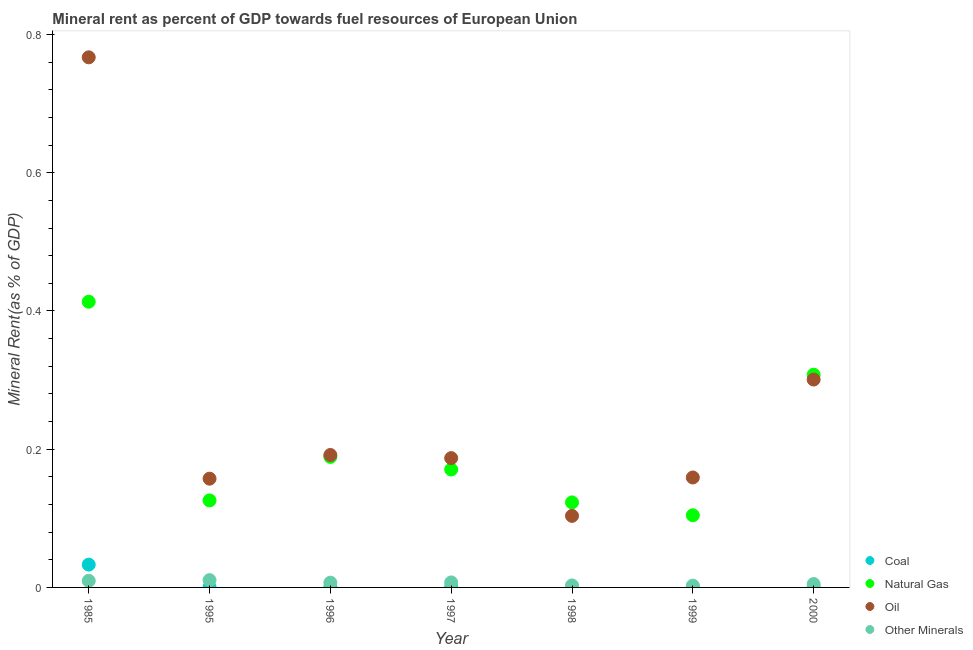Is the number of dotlines equal to the number of legend labels?
Keep it short and to the point. Yes. What is the  rent of other minerals in 1985?
Your response must be concise. 0.01. Across all years, what is the maximum oil rent?
Your response must be concise. 0.77. Across all years, what is the minimum oil rent?
Provide a short and direct response. 0.1. In which year was the oil rent minimum?
Provide a succinct answer. 1998. What is the total oil rent in the graph?
Your answer should be compact. 1.87. What is the difference between the natural gas rent in 1996 and that in 1998?
Your answer should be very brief. 0.07. What is the difference between the coal rent in 1985 and the oil rent in 1998?
Ensure brevity in your answer.  -0.07. What is the average natural gas rent per year?
Your answer should be compact. 0.2. In the year 1999, what is the difference between the oil rent and coal rent?
Ensure brevity in your answer.  0.16. What is the ratio of the  rent of other minerals in 1985 to that in 1996?
Provide a short and direct response. 1.39. What is the difference between the highest and the second highest natural gas rent?
Give a very brief answer. 0.11. What is the difference between the highest and the lowest oil rent?
Make the answer very short. 0.66. In how many years, is the natural gas rent greater than the average natural gas rent taken over all years?
Make the answer very short. 2. Is the sum of the natural gas rent in 1995 and 2000 greater than the maximum oil rent across all years?
Make the answer very short. No. Does the natural gas rent monotonically increase over the years?
Offer a very short reply. No. Is the  rent of other minerals strictly greater than the oil rent over the years?
Make the answer very short. No. Is the natural gas rent strictly less than the  rent of other minerals over the years?
Your answer should be compact. No. Are the values on the major ticks of Y-axis written in scientific E-notation?
Keep it short and to the point. No. Does the graph contain any zero values?
Offer a very short reply. No. Does the graph contain grids?
Keep it short and to the point. No. Where does the legend appear in the graph?
Provide a short and direct response. Bottom right. How many legend labels are there?
Your response must be concise. 4. What is the title of the graph?
Ensure brevity in your answer.  Mineral rent as percent of GDP towards fuel resources of European Union. What is the label or title of the X-axis?
Provide a short and direct response. Year. What is the label or title of the Y-axis?
Offer a very short reply. Mineral Rent(as % of GDP). What is the Mineral Rent(as % of GDP) in Coal in 1985?
Make the answer very short. 0.03. What is the Mineral Rent(as % of GDP) in Natural Gas in 1985?
Ensure brevity in your answer.  0.41. What is the Mineral Rent(as % of GDP) in Oil in 1985?
Your answer should be compact. 0.77. What is the Mineral Rent(as % of GDP) of Other Minerals in 1985?
Provide a succinct answer. 0.01. What is the Mineral Rent(as % of GDP) of Coal in 1995?
Your answer should be very brief. 0. What is the Mineral Rent(as % of GDP) in Natural Gas in 1995?
Offer a terse response. 0.13. What is the Mineral Rent(as % of GDP) in Oil in 1995?
Make the answer very short. 0.16. What is the Mineral Rent(as % of GDP) of Other Minerals in 1995?
Keep it short and to the point. 0.01. What is the Mineral Rent(as % of GDP) of Coal in 1996?
Make the answer very short. 0. What is the Mineral Rent(as % of GDP) of Natural Gas in 1996?
Your response must be concise. 0.19. What is the Mineral Rent(as % of GDP) in Oil in 1996?
Offer a very short reply. 0.19. What is the Mineral Rent(as % of GDP) of Other Minerals in 1996?
Your answer should be very brief. 0.01. What is the Mineral Rent(as % of GDP) in Coal in 1997?
Offer a very short reply. 0. What is the Mineral Rent(as % of GDP) of Natural Gas in 1997?
Keep it short and to the point. 0.17. What is the Mineral Rent(as % of GDP) of Oil in 1997?
Give a very brief answer. 0.19. What is the Mineral Rent(as % of GDP) of Other Minerals in 1997?
Your answer should be very brief. 0.01. What is the Mineral Rent(as % of GDP) of Coal in 1998?
Your answer should be compact. 0. What is the Mineral Rent(as % of GDP) of Natural Gas in 1998?
Ensure brevity in your answer.  0.12. What is the Mineral Rent(as % of GDP) of Oil in 1998?
Give a very brief answer. 0.1. What is the Mineral Rent(as % of GDP) in Other Minerals in 1998?
Ensure brevity in your answer.  0. What is the Mineral Rent(as % of GDP) of Coal in 1999?
Provide a short and direct response. 7.968829103317441e-5. What is the Mineral Rent(as % of GDP) in Natural Gas in 1999?
Offer a terse response. 0.1. What is the Mineral Rent(as % of GDP) of Oil in 1999?
Offer a terse response. 0.16. What is the Mineral Rent(as % of GDP) in Other Minerals in 1999?
Your answer should be compact. 0. What is the Mineral Rent(as % of GDP) in Coal in 2000?
Make the answer very short. 0. What is the Mineral Rent(as % of GDP) of Natural Gas in 2000?
Your answer should be very brief. 0.31. What is the Mineral Rent(as % of GDP) of Oil in 2000?
Your answer should be very brief. 0.3. What is the Mineral Rent(as % of GDP) in Other Minerals in 2000?
Keep it short and to the point. 0. Across all years, what is the maximum Mineral Rent(as % of GDP) in Coal?
Offer a very short reply. 0.03. Across all years, what is the maximum Mineral Rent(as % of GDP) in Natural Gas?
Provide a succinct answer. 0.41. Across all years, what is the maximum Mineral Rent(as % of GDP) in Oil?
Provide a succinct answer. 0.77. Across all years, what is the maximum Mineral Rent(as % of GDP) of Other Minerals?
Keep it short and to the point. 0.01. Across all years, what is the minimum Mineral Rent(as % of GDP) in Coal?
Offer a very short reply. 7.968829103317441e-5. Across all years, what is the minimum Mineral Rent(as % of GDP) in Natural Gas?
Provide a succinct answer. 0.1. Across all years, what is the minimum Mineral Rent(as % of GDP) of Oil?
Offer a very short reply. 0.1. Across all years, what is the minimum Mineral Rent(as % of GDP) of Other Minerals?
Ensure brevity in your answer.  0. What is the total Mineral Rent(as % of GDP) of Coal in the graph?
Ensure brevity in your answer.  0.03. What is the total Mineral Rent(as % of GDP) in Natural Gas in the graph?
Offer a terse response. 1.43. What is the total Mineral Rent(as % of GDP) of Oil in the graph?
Your response must be concise. 1.87. What is the total Mineral Rent(as % of GDP) in Other Minerals in the graph?
Provide a short and direct response. 0.04. What is the difference between the Mineral Rent(as % of GDP) of Coal in 1985 and that in 1995?
Provide a short and direct response. 0.03. What is the difference between the Mineral Rent(as % of GDP) of Natural Gas in 1985 and that in 1995?
Make the answer very short. 0.29. What is the difference between the Mineral Rent(as % of GDP) in Oil in 1985 and that in 1995?
Keep it short and to the point. 0.61. What is the difference between the Mineral Rent(as % of GDP) in Other Minerals in 1985 and that in 1995?
Your answer should be very brief. -0. What is the difference between the Mineral Rent(as % of GDP) in Coal in 1985 and that in 1996?
Give a very brief answer. 0.03. What is the difference between the Mineral Rent(as % of GDP) in Natural Gas in 1985 and that in 1996?
Keep it short and to the point. 0.22. What is the difference between the Mineral Rent(as % of GDP) of Oil in 1985 and that in 1996?
Your answer should be compact. 0.58. What is the difference between the Mineral Rent(as % of GDP) of Other Minerals in 1985 and that in 1996?
Offer a very short reply. 0. What is the difference between the Mineral Rent(as % of GDP) of Coal in 1985 and that in 1997?
Ensure brevity in your answer.  0.03. What is the difference between the Mineral Rent(as % of GDP) of Natural Gas in 1985 and that in 1997?
Offer a terse response. 0.24. What is the difference between the Mineral Rent(as % of GDP) in Oil in 1985 and that in 1997?
Give a very brief answer. 0.58. What is the difference between the Mineral Rent(as % of GDP) of Other Minerals in 1985 and that in 1997?
Make the answer very short. 0. What is the difference between the Mineral Rent(as % of GDP) of Coal in 1985 and that in 1998?
Keep it short and to the point. 0.03. What is the difference between the Mineral Rent(as % of GDP) in Natural Gas in 1985 and that in 1998?
Your answer should be compact. 0.29. What is the difference between the Mineral Rent(as % of GDP) of Oil in 1985 and that in 1998?
Your answer should be very brief. 0.66. What is the difference between the Mineral Rent(as % of GDP) in Other Minerals in 1985 and that in 1998?
Your answer should be compact. 0.01. What is the difference between the Mineral Rent(as % of GDP) in Coal in 1985 and that in 1999?
Provide a succinct answer. 0.03. What is the difference between the Mineral Rent(as % of GDP) of Natural Gas in 1985 and that in 1999?
Give a very brief answer. 0.31. What is the difference between the Mineral Rent(as % of GDP) in Oil in 1985 and that in 1999?
Your answer should be compact. 0.61. What is the difference between the Mineral Rent(as % of GDP) of Other Minerals in 1985 and that in 1999?
Provide a short and direct response. 0.01. What is the difference between the Mineral Rent(as % of GDP) of Coal in 1985 and that in 2000?
Make the answer very short. 0.03. What is the difference between the Mineral Rent(as % of GDP) in Natural Gas in 1985 and that in 2000?
Provide a short and direct response. 0.11. What is the difference between the Mineral Rent(as % of GDP) in Oil in 1985 and that in 2000?
Provide a short and direct response. 0.47. What is the difference between the Mineral Rent(as % of GDP) of Other Minerals in 1985 and that in 2000?
Give a very brief answer. 0. What is the difference between the Mineral Rent(as % of GDP) in Natural Gas in 1995 and that in 1996?
Your answer should be compact. -0.06. What is the difference between the Mineral Rent(as % of GDP) in Oil in 1995 and that in 1996?
Give a very brief answer. -0.03. What is the difference between the Mineral Rent(as % of GDP) of Other Minerals in 1995 and that in 1996?
Give a very brief answer. 0. What is the difference between the Mineral Rent(as % of GDP) in Coal in 1995 and that in 1997?
Provide a short and direct response. 0. What is the difference between the Mineral Rent(as % of GDP) in Natural Gas in 1995 and that in 1997?
Your answer should be compact. -0.04. What is the difference between the Mineral Rent(as % of GDP) in Oil in 1995 and that in 1997?
Keep it short and to the point. -0.03. What is the difference between the Mineral Rent(as % of GDP) of Other Minerals in 1995 and that in 1997?
Provide a succinct answer. 0. What is the difference between the Mineral Rent(as % of GDP) of Coal in 1995 and that in 1998?
Your answer should be compact. 0. What is the difference between the Mineral Rent(as % of GDP) in Natural Gas in 1995 and that in 1998?
Make the answer very short. 0. What is the difference between the Mineral Rent(as % of GDP) of Oil in 1995 and that in 1998?
Offer a very short reply. 0.05. What is the difference between the Mineral Rent(as % of GDP) of Other Minerals in 1995 and that in 1998?
Offer a very short reply. 0.01. What is the difference between the Mineral Rent(as % of GDP) of Natural Gas in 1995 and that in 1999?
Provide a short and direct response. 0.02. What is the difference between the Mineral Rent(as % of GDP) in Oil in 1995 and that in 1999?
Provide a short and direct response. -0. What is the difference between the Mineral Rent(as % of GDP) in Other Minerals in 1995 and that in 1999?
Your answer should be compact. 0.01. What is the difference between the Mineral Rent(as % of GDP) of Coal in 1995 and that in 2000?
Your answer should be very brief. 0. What is the difference between the Mineral Rent(as % of GDP) in Natural Gas in 1995 and that in 2000?
Your response must be concise. -0.18. What is the difference between the Mineral Rent(as % of GDP) in Oil in 1995 and that in 2000?
Your answer should be very brief. -0.14. What is the difference between the Mineral Rent(as % of GDP) in Other Minerals in 1995 and that in 2000?
Provide a short and direct response. 0.01. What is the difference between the Mineral Rent(as % of GDP) of Natural Gas in 1996 and that in 1997?
Give a very brief answer. 0.02. What is the difference between the Mineral Rent(as % of GDP) of Oil in 1996 and that in 1997?
Your answer should be very brief. 0. What is the difference between the Mineral Rent(as % of GDP) in Other Minerals in 1996 and that in 1997?
Provide a short and direct response. -0. What is the difference between the Mineral Rent(as % of GDP) in Natural Gas in 1996 and that in 1998?
Your answer should be very brief. 0.07. What is the difference between the Mineral Rent(as % of GDP) of Oil in 1996 and that in 1998?
Your answer should be compact. 0.09. What is the difference between the Mineral Rent(as % of GDP) of Other Minerals in 1996 and that in 1998?
Keep it short and to the point. 0. What is the difference between the Mineral Rent(as % of GDP) of Natural Gas in 1996 and that in 1999?
Provide a short and direct response. 0.08. What is the difference between the Mineral Rent(as % of GDP) of Oil in 1996 and that in 1999?
Your answer should be compact. 0.03. What is the difference between the Mineral Rent(as % of GDP) in Other Minerals in 1996 and that in 1999?
Provide a succinct answer. 0. What is the difference between the Mineral Rent(as % of GDP) of Coal in 1996 and that in 2000?
Make the answer very short. 0. What is the difference between the Mineral Rent(as % of GDP) of Natural Gas in 1996 and that in 2000?
Provide a short and direct response. -0.12. What is the difference between the Mineral Rent(as % of GDP) of Oil in 1996 and that in 2000?
Your answer should be very brief. -0.11. What is the difference between the Mineral Rent(as % of GDP) in Other Minerals in 1996 and that in 2000?
Your answer should be compact. 0. What is the difference between the Mineral Rent(as % of GDP) in Natural Gas in 1997 and that in 1998?
Offer a very short reply. 0.05. What is the difference between the Mineral Rent(as % of GDP) in Oil in 1997 and that in 1998?
Ensure brevity in your answer.  0.08. What is the difference between the Mineral Rent(as % of GDP) of Other Minerals in 1997 and that in 1998?
Make the answer very short. 0. What is the difference between the Mineral Rent(as % of GDP) in Natural Gas in 1997 and that in 1999?
Ensure brevity in your answer.  0.07. What is the difference between the Mineral Rent(as % of GDP) of Oil in 1997 and that in 1999?
Provide a short and direct response. 0.03. What is the difference between the Mineral Rent(as % of GDP) in Other Minerals in 1997 and that in 1999?
Offer a terse response. 0. What is the difference between the Mineral Rent(as % of GDP) of Coal in 1997 and that in 2000?
Your response must be concise. 0. What is the difference between the Mineral Rent(as % of GDP) of Natural Gas in 1997 and that in 2000?
Your answer should be compact. -0.14. What is the difference between the Mineral Rent(as % of GDP) in Oil in 1997 and that in 2000?
Make the answer very short. -0.11. What is the difference between the Mineral Rent(as % of GDP) of Other Minerals in 1997 and that in 2000?
Your response must be concise. 0. What is the difference between the Mineral Rent(as % of GDP) in Natural Gas in 1998 and that in 1999?
Your response must be concise. 0.02. What is the difference between the Mineral Rent(as % of GDP) in Oil in 1998 and that in 1999?
Offer a terse response. -0.06. What is the difference between the Mineral Rent(as % of GDP) in Natural Gas in 1998 and that in 2000?
Your answer should be compact. -0.18. What is the difference between the Mineral Rent(as % of GDP) in Oil in 1998 and that in 2000?
Keep it short and to the point. -0.2. What is the difference between the Mineral Rent(as % of GDP) in Other Minerals in 1998 and that in 2000?
Give a very brief answer. -0. What is the difference between the Mineral Rent(as % of GDP) of Coal in 1999 and that in 2000?
Offer a terse response. -0. What is the difference between the Mineral Rent(as % of GDP) in Natural Gas in 1999 and that in 2000?
Give a very brief answer. -0.2. What is the difference between the Mineral Rent(as % of GDP) in Oil in 1999 and that in 2000?
Your answer should be compact. -0.14. What is the difference between the Mineral Rent(as % of GDP) of Other Minerals in 1999 and that in 2000?
Offer a very short reply. -0. What is the difference between the Mineral Rent(as % of GDP) of Coal in 1985 and the Mineral Rent(as % of GDP) of Natural Gas in 1995?
Offer a very short reply. -0.09. What is the difference between the Mineral Rent(as % of GDP) of Coal in 1985 and the Mineral Rent(as % of GDP) of Oil in 1995?
Give a very brief answer. -0.12. What is the difference between the Mineral Rent(as % of GDP) of Coal in 1985 and the Mineral Rent(as % of GDP) of Other Minerals in 1995?
Offer a very short reply. 0.02. What is the difference between the Mineral Rent(as % of GDP) of Natural Gas in 1985 and the Mineral Rent(as % of GDP) of Oil in 1995?
Keep it short and to the point. 0.26. What is the difference between the Mineral Rent(as % of GDP) of Natural Gas in 1985 and the Mineral Rent(as % of GDP) of Other Minerals in 1995?
Provide a succinct answer. 0.4. What is the difference between the Mineral Rent(as % of GDP) of Oil in 1985 and the Mineral Rent(as % of GDP) of Other Minerals in 1995?
Provide a succinct answer. 0.76. What is the difference between the Mineral Rent(as % of GDP) of Coal in 1985 and the Mineral Rent(as % of GDP) of Natural Gas in 1996?
Make the answer very short. -0.16. What is the difference between the Mineral Rent(as % of GDP) in Coal in 1985 and the Mineral Rent(as % of GDP) in Oil in 1996?
Make the answer very short. -0.16. What is the difference between the Mineral Rent(as % of GDP) of Coal in 1985 and the Mineral Rent(as % of GDP) of Other Minerals in 1996?
Provide a short and direct response. 0.03. What is the difference between the Mineral Rent(as % of GDP) of Natural Gas in 1985 and the Mineral Rent(as % of GDP) of Oil in 1996?
Your response must be concise. 0.22. What is the difference between the Mineral Rent(as % of GDP) in Natural Gas in 1985 and the Mineral Rent(as % of GDP) in Other Minerals in 1996?
Offer a terse response. 0.41. What is the difference between the Mineral Rent(as % of GDP) of Oil in 1985 and the Mineral Rent(as % of GDP) of Other Minerals in 1996?
Provide a succinct answer. 0.76. What is the difference between the Mineral Rent(as % of GDP) of Coal in 1985 and the Mineral Rent(as % of GDP) of Natural Gas in 1997?
Your answer should be compact. -0.14. What is the difference between the Mineral Rent(as % of GDP) of Coal in 1985 and the Mineral Rent(as % of GDP) of Oil in 1997?
Ensure brevity in your answer.  -0.15. What is the difference between the Mineral Rent(as % of GDP) of Coal in 1985 and the Mineral Rent(as % of GDP) of Other Minerals in 1997?
Provide a succinct answer. 0.03. What is the difference between the Mineral Rent(as % of GDP) of Natural Gas in 1985 and the Mineral Rent(as % of GDP) of Oil in 1997?
Your response must be concise. 0.23. What is the difference between the Mineral Rent(as % of GDP) of Natural Gas in 1985 and the Mineral Rent(as % of GDP) of Other Minerals in 1997?
Offer a very short reply. 0.41. What is the difference between the Mineral Rent(as % of GDP) of Oil in 1985 and the Mineral Rent(as % of GDP) of Other Minerals in 1997?
Ensure brevity in your answer.  0.76. What is the difference between the Mineral Rent(as % of GDP) of Coal in 1985 and the Mineral Rent(as % of GDP) of Natural Gas in 1998?
Offer a very short reply. -0.09. What is the difference between the Mineral Rent(as % of GDP) in Coal in 1985 and the Mineral Rent(as % of GDP) in Oil in 1998?
Provide a short and direct response. -0.07. What is the difference between the Mineral Rent(as % of GDP) in Coal in 1985 and the Mineral Rent(as % of GDP) in Other Minerals in 1998?
Keep it short and to the point. 0.03. What is the difference between the Mineral Rent(as % of GDP) of Natural Gas in 1985 and the Mineral Rent(as % of GDP) of Oil in 1998?
Give a very brief answer. 0.31. What is the difference between the Mineral Rent(as % of GDP) of Natural Gas in 1985 and the Mineral Rent(as % of GDP) of Other Minerals in 1998?
Make the answer very short. 0.41. What is the difference between the Mineral Rent(as % of GDP) in Oil in 1985 and the Mineral Rent(as % of GDP) in Other Minerals in 1998?
Ensure brevity in your answer.  0.76. What is the difference between the Mineral Rent(as % of GDP) of Coal in 1985 and the Mineral Rent(as % of GDP) of Natural Gas in 1999?
Your answer should be very brief. -0.07. What is the difference between the Mineral Rent(as % of GDP) in Coal in 1985 and the Mineral Rent(as % of GDP) in Oil in 1999?
Offer a very short reply. -0.13. What is the difference between the Mineral Rent(as % of GDP) of Coal in 1985 and the Mineral Rent(as % of GDP) of Other Minerals in 1999?
Give a very brief answer. 0.03. What is the difference between the Mineral Rent(as % of GDP) of Natural Gas in 1985 and the Mineral Rent(as % of GDP) of Oil in 1999?
Give a very brief answer. 0.25. What is the difference between the Mineral Rent(as % of GDP) in Natural Gas in 1985 and the Mineral Rent(as % of GDP) in Other Minerals in 1999?
Your answer should be compact. 0.41. What is the difference between the Mineral Rent(as % of GDP) of Oil in 1985 and the Mineral Rent(as % of GDP) of Other Minerals in 1999?
Offer a very short reply. 0.76. What is the difference between the Mineral Rent(as % of GDP) in Coal in 1985 and the Mineral Rent(as % of GDP) in Natural Gas in 2000?
Your answer should be compact. -0.27. What is the difference between the Mineral Rent(as % of GDP) of Coal in 1985 and the Mineral Rent(as % of GDP) of Oil in 2000?
Make the answer very short. -0.27. What is the difference between the Mineral Rent(as % of GDP) in Coal in 1985 and the Mineral Rent(as % of GDP) in Other Minerals in 2000?
Provide a succinct answer. 0.03. What is the difference between the Mineral Rent(as % of GDP) of Natural Gas in 1985 and the Mineral Rent(as % of GDP) of Oil in 2000?
Offer a very short reply. 0.11. What is the difference between the Mineral Rent(as % of GDP) in Natural Gas in 1985 and the Mineral Rent(as % of GDP) in Other Minerals in 2000?
Provide a succinct answer. 0.41. What is the difference between the Mineral Rent(as % of GDP) in Oil in 1985 and the Mineral Rent(as % of GDP) in Other Minerals in 2000?
Offer a very short reply. 0.76. What is the difference between the Mineral Rent(as % of GDP) in Coal in 1995 and the Mineral Rent(as % of GDP) in Natural Gas in 1996?
Keep it short and to the point. -0.19. What is the difference between the Mineral Rent(as % of GDP) in Coal in 1995 and the Mineral Rent(as % of GDP) in Oil in 1996?
Make the answer very short. -0.19. What is the difference between the Mineral Rent(as % of GDP) of Coal in 1995 and the Mineral Rent(as % of GDP) of Other Minerals in 1996?
Your response must be concise. -0.01. What is the difference between the Mineral Rent(as % of GDP) in Natural Gas in 1995 and the Mineral Rent(as % of GDP) in Oil in 1996?
Ensure brevity in your answer.  -0.07. What is the difference between the Mineral Rent(as % of GDP) of Natural Gas in 1995 and the Mineral Rent(as % of GDP) of Other Minerals in 1996?
Your answer should be very brief. 0.12. What is the difference between the Mineral Rent(as % of GDP) of Oil in 1995 and the Mineral Rent(as % of GDP) of Other Minerals in 1996?
Make the answer very short. 0.15. What is the difference between the Mineral Rent(as % of GDP) of Coal in 1995 and the Mineral Rent(as % of GDP) of Natural Gas in 1997?
Provide a short and direct response. -0.17. What is the difference between the Mineral Rent(as % of GDP) in Coal in 1995 and the Mineral Rent(as % of GDP) in Oil in 1997?
Offer a terse response. -0.19. What is the difference between the Mineral Rent(as % of GDP) in Coal in 1995 and the Mineral Rent(as % of GDP) in Other Minerals in 1997?
Make the answer very short. -0.01. What is the difference between the Mineral Rent(as % of GDP) of Natural Gas in 1995 and the Mineral Rent(as % of GDP) of Oil in 1997?
Your answer should be compact. -0.06. What is the difference between the Mineral Rent(as % of GDP) in Natural Gas in 1995 and the Mineral Rent(as % of GDP) in Other Minerals in 1997?
Offer a very short reply. 0.12. What is the difference between the Mineral Rent(as % of GDP) of Oil in 1995 and the Mineral Rent(as % of GDP) of Other Minerals in 1997?
Your answer should be very brief. 0.15. What is the difference between the Mineral Rent(as % of GDP) of Coal in 1995 and the Mineral Rent(as % of GDP) of Natural Gas in 1998?
Give a very brief answer. -0.12. What is the difference between the Mineral Rent(as % of GDP) in Coal in 1995 and the Mineral Rent(as % of GDP) in Oil in 1998?
Keep it short and to the point. -0.1. What is the difference between the Mineral Rent(as % of GDP) in Coal in 1995 and the Mineral Rent(as % of GDP) in Other Minerals in 1998?
Give a very brief answer. -0. What is the difference between the Mineral Rent(as % of GDP) of Natural Gas in 1995 and the Mineral Rent(as % of GDP) of Oil in 1998?
Your answer should be compact. 0.02. What is the difference between the Mineral Rent(as % of GDP) of Natural Gas in 1995 and the Mineral Rent(as % of GDP) of Other Minerals in 1998?
Provide a short and direct response. 0.12. What is the difference between the Mineral Rent(as % of GDP) in Oil in 1995 and the Mineral Rent(as % of GDP) in Other Minerals in 1998?
Give a very brief answer. 0.15. What is the difference between the Mineral Rent(as % of GDP) in Coal in 1995 and the Mineral Rent(as % of GDP) in Natural Gas in 1999?
Offer a very short reply. -0.1. What is the difference between the Mineral Rent(as % of GDP) in Coal in 1995 and the Mineral Rent(as % of GDP) in Oil in 1999?
Your answer should be very brief. -0.16. What is the difference between the Mineral Rent(as % of GDP) in Coal in 1995 and the Mineral Rent(as % of GDP) in Other Minerals in 1999?
Your answer should be very brief. -0. What is the difference between the Mineral Rent(as % of GDP) of Natural Gas in 1995 and the Mineral Rent(as % of GDP) of Oil in 1999?
Offer a very short reply. -0.03. What is the difference between the Mineral Rent(as % of GDP) of Natural Gas in 1995 and the Mineral Rent(as % of GDP) of Other Minerals in 1999?
Ensure brevity in your answer.  0.12. What is the difference between the Mineral Rent(as % of GDP) in Oil in 1995 and the Mineral Rent(as % of GDP) in Other Minerals in 1999?
Make the answer very short. 0.15. What is the difference between the Mineral Rent(as % of GDP) in Coal in 1995 and the Mineral Rent(as % of GDP) in Natural Gas in 2000?
Offer a very short reply. -0.31. What is the difference between the Mineral Rent(as % of GDP) in Coal in 1995 and the Mineral Rent(as % of GDP) in Oil in 2000?
Provide a short and direct response. -0.3. What is the difference between the Mineral Rent(as % of GDP) of Coal in 1995 and the Mineral Rent(as % of GDP) of Other Minerals in 2000?
Make the answer very short. -0. What is the difference between the Mineral Rent(as % of GDP) of Natural Gas in 1995 and the Mineral Rent(as % of GDP) of Oil in 2000?
Offer a terse response. -0.17. What is the difference between the Mineral Rent(as % of GDP) in Natural Gas in 1995 and the Mineral Rent(as % of GDP) in Other Minerals in 2000?
Offer a terse response. 0.12. What is the difference between the Mineral Rent(as % of GDP) in Oil in 1995 and the Mineral Rent(as % of GDP) in Other Minerals in 2000?
Your response must be concise. 0.15. What is the difference between the Mineral Rent(as % of GDP) of Coal in 1996 and the Mineral Rent(as % of GDP) of Natural Gas in 1997?
Offer a terse response. -0.17. What is the difference between the Mineral Rent(as % of GDP) in Coal in 1996 and the Mineral Rent(as % of GDP) in Oil in 1997?
Your answer should be compact. -0.19. What is the difference between the Mineral Rent(as % of GDP) of Coal in 1996 and the Mineral Rent(as % of GDP) of Other Minerals in 1997?
Your response must be concise. -0.01. What is the difference between the Mineral Rent(as % of GDP) in Natural Gas in 1996 and the Mineral Rent(as % of GDP) in Oil in 1997?
Give a very brief answer. 0. What is the difference between the Mineral Rent(as % of GDP) in Natural Gas in 1996 and the Mineral Rent(as % of GDP) in Other Minerals in 1997?
Offer a very short reply. 0.18. What is the difference between the Mineral Rent(as % of GDP) of Oil in 1996 and the Mineral Rent(as % of GDP) of Other Minerals in 1997?
Keep it short and to the point. 0.18. What is the difference between the Mineral Rent(as % of GDP) of Coal in 1996 and the Mineral Rent(as % of GDP) of Natural Gas in 1998?
Make the answer very short. -0.12. What is the difference between the Mineral Rent(as % of GDP) in Coal in 1996 and the Mineral Rent(as % of GDP) in Oil in 1998?
Offer a very short reply. -0.1. What is the difference between the Mineral Rent(as % of GDP) in Coal in 1996 and the Mineral Rent(as % of GDP) in Other Minerals in 1998?
Offer a terse response. -0. What is the difference between the Mineral Rent(as % of GDP) in Natural Gas in 1996 and the Mineral Rent(as % of GDP) in Oil in 1998?
Offer a very short reply. 0.09. What is the difference between the Mineral Rent(as % of GDP) of Natural Gas in 1996 and the Mineral Rent(as % of GDP) of Other Minerals in 1998?
Make the answer very short. 0.19. What is the difference between the Mineral Rent(as % of GDP) in Oil in 1996 and the Mineral Rent(as % of GDP) in Other Minerals in 1998?
Offer a terse response. 0.19. What is the difference between the Mineral Rent(as % of GDP) of Coal in 1996 and the Mineral Rent(as % of GDP) of Natural Gas in 1999?
Keep it short and to the point. -0.1. What is the difference between the Mineral Rent(as % of GDP) in Coal in 1996 and the Mineral Rent(as % of GDP) in Oil in 1999?
Offer a terse response. -0.16. What is the difference between the Mineral Rent(as % of GDP) of Coal in 1996 and the Mineral Rent(as % of GDP) of Other Minerals in 1999?
Keep it short and to the point. -0. What is the difference between the Mineral Rent(as % of GDP) in Natural Gas in 1996 and the Mineral Rent(as % of GDP) in Oil in 1999?
Offer a very short reply. 0.03. What is the difference between the Mineral Rent(as % of GDP) in Natural Gas in 1996 and the Mineral Rent(as % of GDP) in Other Minerals in 1999?
Offer a terse response. 0.19. What is the difference between the Mineral Rent(as % of GDP) in Oil in 1996 and the Mineral Rent(as % of GDP) in Other Minerals in 1999?
Offer a very short reply. 0.19. What is the difference between the Mineral Rent(as % of GDP) in Coal in 1996 and the Mineral Rent(as % of GDP) in Natural Gas in 2000?
Your answer should be very brief. -0.31. What is the difference between the Mineral Rent(as % of GDP) of Coal in 1996 and the Mineral Rent(as % of GDP) of Oil in 2000?
Offer a very short reply. -0.3. What is the difference between the Mineral Rent(as % of GDP) in Coal in 1996 and the Mineral Rent(as % of GDP) in Other Minerals in 2000?
Offer a terse response. -0. What is the difference between the Mineral Rent(as % of GDP) of Natural Gas in 1996 and the Mineral Rent(as % of GDP) of Oil in 2000?
Provide a short and direct response. -0.11. What is the difference between the Mineral Rent(as % of GDP) of Natural Gas in 1996 and the Mineral Rent(as % of GDP) of Other Minerals in 2000?
Your answer should be compact. 0.18. What is the difference between the Mineral Rent(as % of GDP) in Oil in 1996 and the Mineral Rent(as % of GDP) in Other Minerals in 2000?
Your answer should be compact. 0.19. What is the difference between the Mineral Rent(as % of GDP) of Coal in 1997 and the Mineral Rent(as % of GDP) of Natural Gas in 1998?
Give a very brief answer. -0.12. What is the difference between the Mineral Rent(as % of GDP) of Coal in 1997 and the Mineral Rent(as % of GDP) of Oil in 1998?
Offer a very short reply. -0.1. What is the difference between the Mineral Rent(as % of GDP) of Coal in 1997 and the Mineral Rent(as % of GDP) of Other Minerals in 1998?
Keep it short and to the point. -0. What is the difference between the Mineral Rent(as % of GDP) in Natural Gas in 1997 and the Mineral Rent(as % of GDP) in Oil in 1998?
Your answer should be compact. 0.07. What is the difference between the Mineral Rent(as % of GDP) in Natural Gas in 1997 and the Mineral Rent(as % of GDP) in Other Minerals in 1998?
Ensure brevity in your answer.  0.17. What is the difference between the Mineral Rent(as % of GDP) of Oil in 1997 and the Mineral Rent(as % of GDP) of Other Minerals in 1998?
Make the answer very short. 0.18. What is the difference between the Mineral Rent(as % of GDP) of Coal in 1997 and the Mineral Rent(as % of GDP) of Natural Gas in 1999?
Your response must be concise. -0.1. What is the difference between the Mineral Rent(as % of GDP) of Coal in 1997 and the Mineral Rent(as % of GDP) of Oil in 1999?
Provide a succinct answer. -0.16. What is the difference between the Mineral Rent(as % of GDP) in Coal in 1997 and the Mineral Rent(as % of GDP) in Other Minerals in 1999?
Offer a terse response. -0. What is the difference between the Mineral Rent(as % of GDP) of Natural Gas in 1997 and the Mineral Rent(as % of GDP) of Oil in 1999?
Your response must be concise. 0.01. What is the difference between the Mineral Rent(as % of GDP) in Natural Gas in 1997 and the Mineral Rent(as % of GDP) in Other Minerals in 1999?
Ensure brevity in your answer.  0.17. What is the difference between the Mineral Rent(as % of GDP) of Oil in 1997 and the Mineral Rent(as % of GDP) of Other Minerals in 1999?
Make the answer very short. 0.18. What is the difference between the Mineral Rent(as % of GDP) in Coal in 1997 and the Mineral Rent(as % of GDP) in Natural Gas in 2000?
Make the answer very short. -0.31. What is the difference between the Mineral Rent(as % of GDP) in Coal in 1997 and the Mineral Rent(as % of GDP) in Oil in 2000?
Your answer should be compact. -0.3. What is the difference between the Mineral Rent(as % of GDP) of Coal in 1997 and the Mineral Rent(as % of GDP) of Other Minerals in 2000?
Make the answer very short. -0. What is the difference between the Mineral Rent(as % of GDP) in Natural Gas in 1997 and the Mineral Rent(as % of GDP) in Oil in 2000?
Provide a succinct answer. -0.13. What is the difference between the Mineral Rent(as % of GDP) in Natural Gas in 1997 and the Mineral Rent(as % of GDP) in Other Minerals in 2000?
Provide a short and direct response. 0.17. What is the difference between the Mineral Rent(as % of GDP) in Oil in 1997 and the Mineral Rent(as % of GDP) in Other Minerals in 2000?
Provide a short and direct response. 0.18. What is the difference between the Mineral Rent(as % of GDP) in Coal in 1998 and the Mineral Rent(as % of GDP) in Natural Gas in 1999?
Make the answer very short. -0.1. What is the difference between the Mineral Rent(as % of GDP) of Coal in 1998 and the Mineral Rent(as % of GDP) of Oil in 1999?
Provide a short and direct response. -0.16. What is the difference between the Mineral Rent(as % of GDP) in Coal in 1998 and the Mineral Rent(as % of GDP) in Other Minerals in 1999?
Your answer should be very brief. -0. What is the difference between the Mineral Rent(as % of GDP) of Natural Gas in 1998 and the Mineral Rent(as % of GDP) of Oil in 1999?
Your response must be concise. -0.04. What is the difference between the Mineral Rent(as % of GDP) of Natural Gas in 1998 and the Mineral Rent(as % of GDP) of Other Minerals in 1999?
Offer a terse response. 0.12. What is the difference between the Mineral Rent(as % of GDP) in Oil in 1998 and the Mineral Rent(as % of GDP) in Other Minerals in 1999?
Your answer should be compact. 0.1. What is the difference between the Mineral Rent(as % of GDP) in Coal in 1998 and the Mineral Rent(as % of GDP) in Natural Gas in 2000?
Provide a short and direct response. -0.31. What is the difference between the Mineral Rent(as % of GDP) of Coal in 1998 and the Mineral Rent(as % of GDP) of Oil in 2000?
Your answer should be very brief. -0.3. What is the difference between the Mineral Rent(as % of GDP) of Coal in 1998 and the Mineral Rent(as % of GDP) of Other Minerals in 2000?
Your response must be concise. -0. What is the difference between the Mineral Rent(as % of GDP) of Natural Gas in 1998 and the Mineral Rent(as % of GDP) of Oil in 2000?
Keep it short and to the point. -0.18. What is the difference between the Mineral Rent(as % of GDP) of Natural Gas in 1998 and the Mineral Rent(as % of GDP) of Other Minerals in 2000?
Provide a succinct answer. 0.12. What is the difference between the Mineral Rent(as % of GDP) in Oil in 1998 and the Mineral Rent(as % of GDP) in Other Minerals in 2000?
Keep it short and to the point. 0.1. What is the difference between the Mineral Rent(as % of GDP) of Coal in 1999 and the Mineral Rent(as % of GDP) of Natural Gas in 2000?
Your answer should be very brief. -0.31. What is the difference between the Mineral Rent(as % of GDP) in Coal in 1999 and the Mineral Rent(as % of GDP) in Oil in 2000?
Make the answer very short. -0.3. What is the difference between the Mineral Rent(as % of GDP) of Coal in 1999 and the Mineral Rent(as % of GDP) of Other Minerals in 2000?
Offer a very short reply. -0. What is the difference between the Mineral Rent(as % of GDP) in Natural Gas in 1999 and the Mineral Rent(as % of GDP) in Oil in 2000?
Keep it short and to the point. -0.2. What is the difference between the Mineral Rent(as % of GDP) in Natural Gas in 1999 and the Mineral Rent(as % of GDP) in Other Minerals in 2000?
Ensure brevity in your answer.  0.1. What is the difference between the Mineral Rent(as % of GDP) in Oil in 1999 and the Mineral Rent(as % of GDP) in Other Minerals in 2000?
Your answer should be very brief. 0.15. What is the average Mineral Rent(as % of GDP) of Coal per year?
Keep it short and to the point. 0.01. What is the average Mineral Rent(as % of GDP) of Natural Gas per year?
Provide a succinct answer. 0.2. What is the average Mineral Rent(as % of GDP) of Oil per year?
Provide a succinct answer. 0.27. What is the average Mineral Rent(as % of GDP) in Other Minerals per year?
Give a very brief answer. 0.01. In the year 1985, what is the difference between the Mineral Rent(as % of GDP) in Coal and Mineral Rent(as % of GDP) in Natural Gas?
Make the answer very short. -0.38. In the year 1985, what is the difference between the Mineral Rent(as % of GDP) in Coal and Mineral Rent(as % of GDP) in Oil?
Your response must be concise. -0.73. In the year 1985, what is the difference between the Mineral Rent(as % of GDP) in Coal and Mineral Rent(as % of GDP) in Other Minerals?
Provide a succinct answer. 0.02. In the year 1985, what is the difference between the Mineral Rent(as % of GDP) in Natural Gas and Mineral Rent(as % of GDP) in Oil?
Give a very brief answer. -0.35. In the year 1985, what is the difference between the Mineral Rent(as % of GDP) in Natural Gas and Mineral Rent(as % of GDP) in Other Minerals?
Your answer should be compact. 0.4. In the year 1985, what is the difference between the Mineral Rent(as % of GDP) in Oil and Mineral Rent(as % of GDP) in Other Minerals?
Your answer should be very brief. 0.76. In the year 1995, what is the difference between the Mineral Rent(as % of GDP) in Coal and Mineral Rent(as % of GDP) in Natural Gas?
Make the answer very short. -0.13. In the year 1995, what is the difference between the Mineral Rent(as % of GDP) of Coal and Mineral Rent(as % of GDP) of Oil?
Offer a terse response. -0.16. In the year 1995, what is the difference between the Mineral Rent(as % of GDP) in Coal and Mineral Rent(as % of GDP) in Other Minerals?
Offer a terse response. -0.01. In the year 1995, what is the difference between the Mineral Rent(as % of GDP) of Natural Gas and Mineral Rent(as % of GDP) of Oil?
Offer a terse response. -0.03. In the year 1995, what is the difference between the Mineral Rent(as % of GDP) in Natural Gas and Mineral Rent(as % of GDP) in Other Minerals?
Make the answer very short. 0.12. In the year 1995, what is the difference between the Mineral Rent(as % of GDP) in Oil and Mineral Rent(as % of GDP) in Other Minerals?
Keep it short and to the point. 0.15. In the year 1996, what is the difference between the Mineral Rent(as % of GDP) in Coal and Mineral Rent(as % of GDP) in Natural Gas?
Offer a terse response. -0.19. In the year 1996, what is the difference between the Mineral Rent(as % of GDP) in Coal and Mineral Rent(as % of GDP) in Oil?
Keep it short and to the point. -0.19. In the year 1996, what is the difference between the Mineral Rent(as % of GDP) in Coal and Mineral Rent(as % of GDP) in Other Minerals?
Provide a succinct answer. -0.01. In the year 1996, what is the difference between the Mineral Rent(as % of GDP) of Natural Gas and Mineral Rent(as % of GDP) of Oil?
Provide a short and direct response. -0. In the year 1996, what is the difference between the Mineral Rent(as % of GDP) in Natural Gas and Mineral Rent(as % of GDP) in Other Minerals?
Offer a very short reply. 0.18. In the year 1996, what is the difference between the Mineral Rent(as % of GDP) in Oil and Mineral Rent(as % of GDP) in Other Minerals?
Give a very brief answer. 0.18. In the year 1997, what is the difference between the Mineral Rent(as % of GDP) in Coal and Mineral Rent(as % of GDP) in Natural Gas?
Give a very brief answer. -0.17. In the year 1997, what is the difference between the Mineral Rent(as % of GDP) of Coal and Mineral Rent(as % of GDP) of Oil?
Ensure brevity in your answer.  -0.19. In the year 1997, what is the difference between the Mineral Rent(as % of GDP) of Coal and Mineral Rent(as % of GDP) of Other Minerals?
Provide a succinct answer. -0.01. In the year 1997, what is the difference between the Mineral Rent(as % of GDP) of Natural Gas and Mineral Rent(as % of GDP) of Oil?
Keep it short and to the point. -0.02. In the year 1997, what is the difference between the Mineral Rent(as % of GDP) of Natural Gas and Mineral Rent(as % of GDP) of Other Minerals?
Offer a very short reply. 0.16. In the year 1997, what is the difference between the Mineral Rent(as % of GDP) in Oil and Mineral Rent(as % of GDP) in Other Minerals?
Your response must be concise. 0.18. In the year 1998, what is the difference between the Mineral Rent(as % of GDP) of Coal and Mineral Rent(as % of GDP) of Natural Gas?
Your response must be concise. -0.12. In the year 1998, what is the difference between the Mineral Rent(as % of GDP) in Coal and Mineral Rent(as % of GDP) in Oil?
Your answer should be compact. -0.1. In the year 1998, what is the difference between the Mineral Rent(as % of GDP) in Coal and Mineral Rent(as % of GDP) in Other Minerals?
Your answer should be very brief. -0. In the year 1998, what is the difference between the Mineral Rent(as % of GDP) in Natural Gas and Mineral Rent(as % of GDP) in Oil?
Make the answer very short. 0.02. In the year 1998, what is the difference between the Mineral Rent(as % of GDP) of Natural Gas and Mineral Rent(as % of GDP) of Other Minerals?
Make the answer very short. 0.12. In the year 1998, what is the difference between the Mineral Rent(as % of GDP) of Oil and Mineral Rent(as % of GDP) of Other Minerals?
Your answer should be compact. 0.1. In the year 1999, what is the difference between the Mineral Rent(as % of GDP) of Coal and Mineral Rent(as % of GDP) of Natural Gas?
Your answer should be very brief. -0.1. In the year 1999, what is the difference between the Mineral Rent(as % of GDP) in Coal and Mineral Rent(as % of GDP) in Oil?
Offer a very short reply. -0.16. In the year 1999, what is the difference between the Mineral Rent(as % of GDP) in Coal and Mineral Rent(as % of GDP) in Other Minerals?
Your answer should be very brief. -0. In the year 1999, what is the difference between the Mineral Rent(as % of GDP) in Natural Gas and Mineral Rent(as % of GDP) in Oil?
Your answer should be very brief. -0.05. In the year 1999, what is the difference between the Mineral Rent(as % of GDP) of Natural Gas and Mineral Rent(as % of GDP) of Other Minerals?
Your answer should be compact. 0.1. In the year 1999, what is the difference between the Mineral Rent(as % of GDP) of Oil and Mineral Rent(as % of GDP) of Other Minerals?
Ensure brevity in your answer.  0.16. In the year 2000, what is the difference between the Mineral Rent(as % of GDP) of Coal and Mineral Rent(as % of GDP) of Natural Gas?
Offer a very short reply. -0.31. In the year 2000, what is the difference between the Mineral Rent(as % of GDP) in Coal and Mineral Rent(as % of GDP) in Oil?
Make the answer very short. -0.3. In the year 2000, what is the difference between the Mineral Rent(as % of GDP) in Coal and Mineral Rent(as % of GDP) in Other Minerals?
Your answer should be compact. -0. In the year 2000, what is the difference between the Mineral Rent(as % of GDP) of Natural Gas and Mineral Rent(as % of GDP) of Oil?
Offer a terse response. 0.01. In the year 2000, what is the difference between the Mineral Rent(as % of GDP) of Natural Gas and Mineral Rent(as % of GDP) of Other Minerals?
Offer a very short reply. 0.3. In the year 2000, what is the difference between the Mineral Rent(as % of GDP) in Oil and Mineral Rent(as % of GDP) in Other Minerals?
Offer a terse response. 0.3. What is the ratio of the Mineral Rent(as % of GDP) in Coal in 1985 to that in 1995?
Offer a very short reply. 60.63. What is the ratio of the Mineral Rent(as % of GDP) in Natural Gas in 1985 to that in 1995?
Your answer should be very brief. 3.28. What is the ratio of the Mineral Rent(as % of GDP) of Oil in 1985 to that in 1995?
Ensure brevity in your answer.  4.87. What is the ratio of the Mineral Rent(as % of GDP) of Other Minerals in 1985 to that in 1995?
Provide a short and direct response. 0.91. What is the ratio of the Mineral Rent(as % of GDP) in Coal in 1985 to that in 1996?
Keep it short and to the point. 64.6. What is the ratio of the Mineral Rent(as % of GDP) of Natural Gas in 1985 to that in 1996?
Your response must be concise. 2.19. What is the ratio of the Mineral Rent(as % of GDP) in Oil in 1985 to that in 1996?
Give a very brief answer. 4. What is the ratio of the Mineral Rent(as % of GDP) of Other Minerals in 1985 to that in 1996?
Ensure brevity in your answer.  1.39. What is the ratio of the Mineral Rent(as % of GDP) in Coal in 1985 to that in 1997?
Keep it short and to the point. 76.06. What is the ratio of the Mineral Rent(as % of GDP) of Natural Gas in 1985 to that in 1997?
Offer a terse response. 2.42. What is the ratio of the Mineral Rent(as % of GDP) in Oil in 1985 to that in 1997?
Offer a terse response. 4.1. What is the ratio of the Mineral Rent(as % of GDP) of Other Minerals in 1985 to that in 1997?
Give a very brief answer. 1.32. What is the ratio of the Mineral Rent(as % of GDP) of Coal in 1985 to that in 1998?
Make the answer very short. 209.71. What is the ratio of the Mineral Rent(as % of GDP) in Natural Gas in 1985 to that in 1998?
Your response must be concise. 3.36. What is the ratio of the Mineral Rent(as % of GDP) in Oil in 1985 to that in 1998?
Your answer should be very brief. 7.41. What is the ratio of the Mineral Rent(as % of GDP) in Other Minerals in 1985 to that in 1998?
Offer a terse response. 3.33. What is the ratio of the Mineral Rent(as % of GDP) of Coal in 1985 to that in 1999?
Ensure brevity in your answer.  414.14. What is the ratio of the Mineral Rent(as % of GDP) in Natural Gas in 1985 to that in 1999?
Offer a terse response. 3.96. What is the ratio of the Mineral Rent(as % of GDP) of Oil in 1985 to that in 1999?
Ensure brevity in your answer.  4.82. What is the ratio of the Mineral Rent(as % of GDP) of Other Minerals in 1985 to that in 1999?
Offer a very short reply. 3.74. What is the ratio of the Mineral Rent(as % of GDP) of Coal in 1985 to that in 2000?
Your answer should be compact. 208.71. What is the ratio of the Mineral Rent(as % of GDP) in Natural Gas in 1985 to that in 2000?
Make the answer very short. 1.34. What is the ratio of the Mineral Rent(as % of GDP) in Oil in 1985 to that in 2000?
Provide a succinct answer. 2.55. What is the ratio of the Mineral Rent(as % of GDP) of Other Minerals in 1985 to that in 2000?
Ensure brevity in your answer.  1.95. What is the ratio of the Mineral Rent(as % of GDP) in Coal in 1995 to that in 1996?
Keep it short and to the point. 1.07. What is the ratio of the Mineral Rent(as % of GDP) in Natural Gas in 1995 to that in 1996?
Provide a succinct answer. 0.67. What is the ratio of the Mineral Rent(as % of GDP) of Oil in 1995 to that in 1996?
Ensure brevity in your answer.  0.82. What is the ratio of the Mineral Rent(as % of GDP) of Other Minerals in 1995 to that in 1996?
Make the answer very short. 1.54. What is the ratio of the Mineral Rent(as % of GDP) of Coal in 1995 to that in 1997?
Your answer should be very brief. 1.25. What is the ratio of the Mineral Rent(as % of GDP) of Natural Gas in 1995 to that in 1997?
Your response must be concise. 0.74. What is the ratio of the Mineral Rent(as % of GDP) in Oil in 1995 to that in 1997?
Your answer should be very brief. 0.84. What is the ratio of the Mineral Rent(as % of GDP) in Other Minerals in 1995 to that in 1997?
Your response must be concise. 1.46. What is the ratio of the Mineral Rent(as % of GDP) in Coal in 1995 to that in 1998?
Your response must be concise. 3.46. What is the ratio of the Mineral Rent(as % of GDP) in Natural Gas in 1995 to that in 1998?
Your answer should be compact. 1.02. What is the ratio of the Mineral Rent(as % of GDP) in Oil in 1995 to that in 1998?
Your answer should be very brief. 1.52. What is the ratio of the Mineral Rent(as % of GDP) of Other Minerals in 1995 to that in 1998?
Provide a short and direct response. 3.67. What is the ratio of the Mineral Rent(as % of GDP) in Coal in 1995 to that in 1999?
Make the answer very short. 6.83. What is the ratio of the Mineral Rent(as % of GDP) in Natural Gas in 1995 to that in 1999?
Your answer should be very brief. 1.21. What is the ratio of the Mineral Rent(as % of GDP) in Other Minerals in 1995 to that in 1999?
Your answer should be compact. 4.13. What is the ratio of the Mineral Rent(as % of GDP) in Coal in 1995 to that in 2000?
Your response must be concise. 3.44. What is the ratio of the Mineral Rent(as % of GDP) in Natural Gas in 1995 to that in 2000?
Make the answer very short. 0.41. What is the ratio of the Mineral Rent(as % of GDP) of Oil in 1995 to that in 2000?
Provide a succinct answer. 0.52. What is the ratio of the Mineral Rent(as % of GDP) in Other Minerals in 1995 to that in 2000?
Provide a succinct answer. 2.15. What is the ratio of the Mineral Rent(as % of GDP) in Coal in 1996 to that in 1997?
Your answer should be very brief. 1.18. What is the ratio of the Mineral Rent(as % of GDP) in Natural Gas in 1996 to that in 1997?
Keep it short and to the point. 1.11. What is the ratio of the Mineral Rent(as % of GDP) of Oil in 1996 to that in 1997?
Offer a terse response. 1.02. What is the ratio of the Mineral Rent(as % of GDP) in Other Minerals in 1996 to that in 1997?
Keep it short and to the point. 0.95. What is the ratio of the Mineral Rent(as % of GDP) in Coal in 1996 to that in 1998?
Provide a succinct answer. 3.25. What is the ratio of the Mineral Rent(as % of GDP) in Natural Gas in 1996 to that in 1998?
Provide a short and direct response. 1.54. What is the ratio of the Mineral Rent(as % of GDP) of Oil in 1996 to that in 1998?
Offer a very short reply. 1.85. What is the ratio of the Mineral Rent(as % of GDP) in Other Minerals in 1996 to that in 1998?
Ensure brevity in your answer.  2.39. What is the ratio of the Mineral Rent(as % of GDP) of Coal in 1996 to that in 1999?
Make the answer very short. 6.41. What is the ratio of the Mineral Rent(as % of GDP) of Natural Gas in 1996 to that in 1999?
Give a very brief answer. 1.81. What is the ratio of the Mineral Rent(as % of GDP) in Oil in 1996 to that in 1999?
Provide a succinct answer. 1.2. What is the ratio of the Mineral Rent(as % of GDP) in Other Minerals in 1996 to that in 1999?
Make the answer very short. 2.69. What is the ratio of the Mineral Rent(as % of GDP) of Coal in 1996 to that in 2000?
Ensure brevity in your answer.  3.23. What is the ratio of the Mineral Rent(as % of GDP) of Natural Gas in 1996 to that in 2000?
Your response must be concise. 0.61. What is the ratio of the Mineral Rent(as % of GDP) in Oil in 1996 to that in 2000?
Keep it short and to the point. 0.64. What is the ratio of the Mineral Rent(as % of GDP) of Other Minerals in 1996 to that in 2000?
Provide a succinct answer. 1.4. What is the ratio of the Mineral Rent(as % of GDP) of Coal in 1997 to that in 1998?
Provide a succinct answer. 2.76. What is the ratio of the Mineral Rent(as % of GDP) of Natural Gas in 1997 to that in 1998?
Make the answer very short. 1.39. What is the ratio of the Mineral Rent(as % of GDP) in Oil in 1997 to that in 1998?
Keep it short and to the point. 1.81. What is the ratio of the Mineral Rent(as % of GDP) in Other Minerals in 1997 to that in 1998?
Make the answer very short. 2.52. What is the ratio of the Mineral Rent(as % of GDP) in Coal in 1997 to that in 1999?
Offer a terse response. 5.44. What is the ratio of the Mineral Rent(as % of GDP) in Natural Gas in 1997 to that in 1999?
Keep it short and to the point. 1.63. What is the ratio of the Mineral Rent(as % of GDP) of Oil in 1997 to that in 1999?
Provide a succinct answer. 1.18. What is the ratio of the Mineral Rent(as % of GDP) of Other Minerals in 1997 to that in 1999?
Give a very brief answer. 2.83. What is the ratio of the Mineral Rent(as % of GDP) in Coal in 1997 to that in 2000?
Your answer should be compact. 2.74. What is the ratio of the Mineral Rent(as % of GDP) in Natural Gas in 1997 to that in 2000?
Your answer should be very brief. 0.55. What is the ratio of the Mineral Rent(as % of GDP) of Oil in 1997 to that in 2000?
Offer a terse response. 0.62. What is the ratio of the Mineral Rent(as % of GDP) in Other Minerals in 1997 to that in 2000?
Ensure brevity in your answer.  1.47. What is the ratio of the Mineral Rent(as % of GDP) in Coal in 1998 to that in 1999?
Give a very brief answer. 1.97. What is the ratio of the Mineral Rent(as % of GDP) in Natural Gas in 1998 to that in 1999?
Your answer should be very brief. 1.18. What is the ratio of the Mineral Rent(as % of GDP) of Oil in 1998 to that in 1999?
Offer a terse response. 0.65. What is the ratio of the Mineral Rent(as % of GDP) in Other Minerals in 1998 to that in 1999?
Your answer should be very brief. 1.12. What is the ratio of the Mineral Rent(as % of GDP) in Natural Gas in 1998 to that in 2000?
Your answer should be compact. 0.4. What is the ratio of the Mineral Rent(as % of GDP) in Oil in 1998 to that in 2000?
Make the answer very short. 0.34. What is the ratio of the Mineral Rent(as % of GDP) of Other Minerals in 1998 to that in 2000?
Your answer should be compact. 0.59. What is the ratio of the Mineral Rent(as % of GDP) in Coal in 1999 to that in 2000?
Offer a very short reply. 0.5. What is the ratio of the Mineral Rent(as % of GDP) of Natural Gas in 1999 to that in 2000?
Provide a short and direct response. 0.34. What is the ratio of the Mineral Rent(as % of GDP) in Oil in 1999 to that in 2000?
Your answer should be very brief. 0.53. What is the ratio of the Mineral Rent(as % of GDP) in Other Minerals in 1999 to that in 2000?
Give a very brief answer. 0.52. What is the difference between the highest and the second highest Mineral Rent(as % of GDP) in Coal?
Ensure brevity in your answer.  0.03. What is the difference between the highest and the second highest Mineral Rent(as % of GDP) of Natural Gas?
Offer a very short reply. 0.11. What is the difference between the highest and the second highest Mineral Rent(as % of GDP) of Oil?
Keep it short and to the point. 0.47. What is the difference between the highest and the second highest Mineral Rent(as % of GDP) in Other Minerals?
Provide a succinct answer. 0. What is the difference between the highest and the lowest Mineral Rent(as % of GDP) of Coal?
Give a very brief answer. 0.03. What is the difference between the highest and the lowest Mineral Rent(as % of GDP) in Natural Gas?
Offer a terse response. 0.31. What is the difference between the highest and the lowest Mineral Rent(as % of GDP) in Oil?
Make the answer very short. 0.66. What is the difference between the highest and the lowest Mineral Rent(as % of GDP) of Other Minerals?
Your response must be concise. 0.01. 